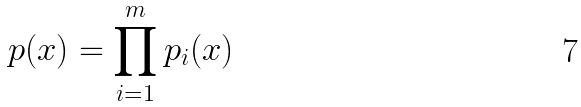<formula> <loc_0><loc_0><loc_500><loc_500>p ( x ) = \prod _ { i = 1 } ^ { m } p _ { i } ( x )</formula> 